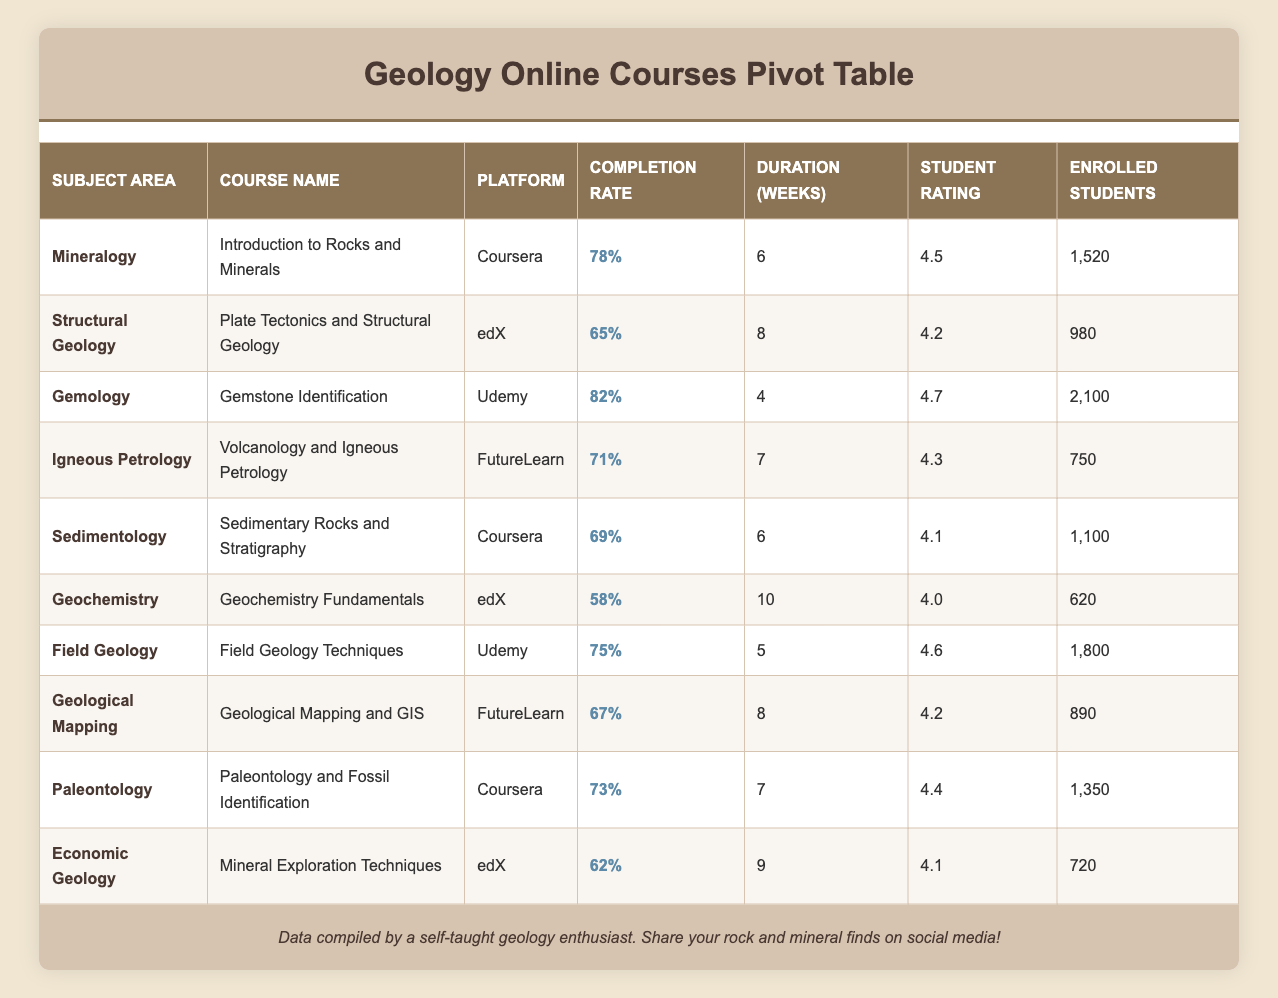What is the highest completion rate among the courses? The highest completion rate listed in the table is 82%, found in the course "Gemstone Identification" on the Udemy platform.
Answer: 82% Which course has the lowest student rating? The lowest student rating in the table is 4.0, associated with the course "Geochemistry Fundamentals" on the edX platform.
Answer: 4.0 What is the average completion rate of the courses offered on Coursera? The courses on Coursera are "Introduction to Rocks and Minerals" (78%), "Sedimentary Rocks and Stratigraphy" (69%), and "Paleontology and Fossil Identification" (73%). The sum is 78 + 69 + 73 = 220, and there are 3 courses, so the average is 220 / 3 = 73.33%.
Answer: 73.33% Are there any courses with a completion rate of 75% or higher? The courses with a completion rate of 75% or higher are "Introduction to Rocks and Minerals" (78%), "Gemstone Identification" (82%), and "Field Geology Techniques" (75%). Thus, the answer is yes.
Answer: Yes Which subject area has the course with the highest number of enrolled students? The course "Gemstone Identification" under the subject area Gemology has the highest number of enrolled students at 2,100. No other course has more enrolled students than this.
Answer: Gemology What is the difference in completion rates between the highest and lowest rates? The highest completion rate is 82% (Gemstone Identification), and the lowest is 58% (Geochemistry Fundamentals). The difference is 82 - 58 = 24%.
Answer: 24% Which course lasts the longest? The course "Geochemistry Fundamentals" has the longest duration of 10 weeks among all the listed courses.
Answer: 10 weeks What is the total number of enrolled students across all courses? To find the total, we sum the enrolled students: 1,520 + 980 + 2,100 + 750 + 1,100 + 620 + 1,800 + 890 + 1,350 + 720 = 12,420.
Answer: 12,420 Which platform has the course with the highest student rating? The course with the highest rating of 4.7, "Gemstone Identification," is offered on Udemy. Therefore, Udemy has the top-rated course based on student ratings.
Answer: Udemy 